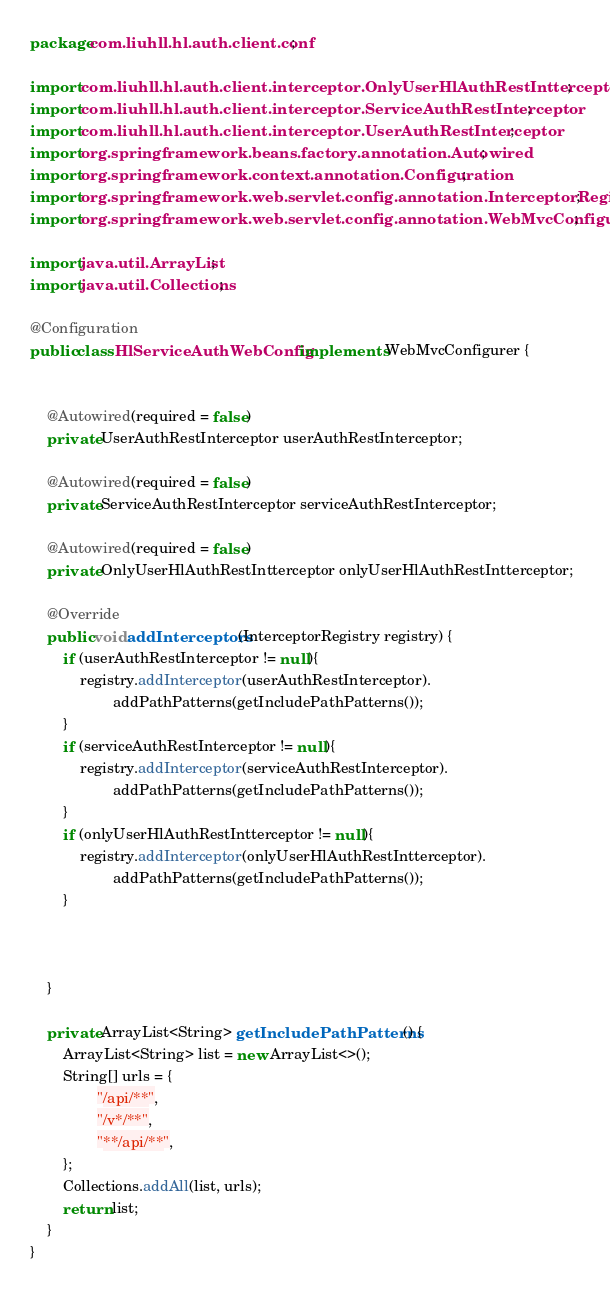<code> <loc_0><loc_0><loc_500><loc_500><_Java_>package com.liuhll.hl.auth.client.conf;

import com.liuhll.hl.auth.client.interceptor.OnlyUserHlAuthRestIntterceptor;
import com.liuhll.hl.auth.client.interceptor.ServiceAuthRestInterceptor;
import com.liuhll.hl.auth.client.interceptor.UserAuthRestInterceptor;
import org.springframework.beans.factory.annotation.Autowired;
import org.springframework.context.annotation.Configuration;
import org.springframework.web.servlet.config.annotation.InterceptorRegistry;
import org.springframework.web.servlet.config.annotation.WebMvcConfigurer;

import java.util.ArrayList;
import java.util.Collections;

@Configuration
public class HlServiceAuthWebConfig implements WebMvcConfigurer {


    @Autowired(required = false)
    private UserAuthRestInterceptor userAuthRestInterceptor;

    @Autowired(required = false)
    private ServiceAuthRestInterceptor serviceAuthRestInterceptor;

    @Autowired(required = false)
    private OnlyUserHlAuthRestIntterceptor onlyUserHlAuthRestIntterceptor;

    @Override
    public void addInterceptors(InterceptorRegistry registry) {
        if (userAuthRestInterceptor != null){
            registry.addInterceptor(userAuthRestInterceptor).
                    addPathPatterns(getIncludePathPatterns());
        }
        if (serviceAuthRestInterceptor != null){
            registry.addInterceptor(serviceAuthRestInterceptor).
                    addPathPatterns(getIncludePathPatterns());
        }
        if (onlyUserHlAuthRestIntterceptor != null){
            registry.addInterceptor(onlyUserHlAuthRestIntterceptor).
                    addPathPatterns(getIncludePathPatterns());
        }



    }

    private ArrayList<String> getIncludePathPatterns() {
        ArrayList<String> list = new ArrayList<>();
        String[] urls = {
                "/api/**",
                "/v*/**",
                "**/api/**",
        };
        Collections.addAll(list, urls);
        return list;
    }
}
</code> 